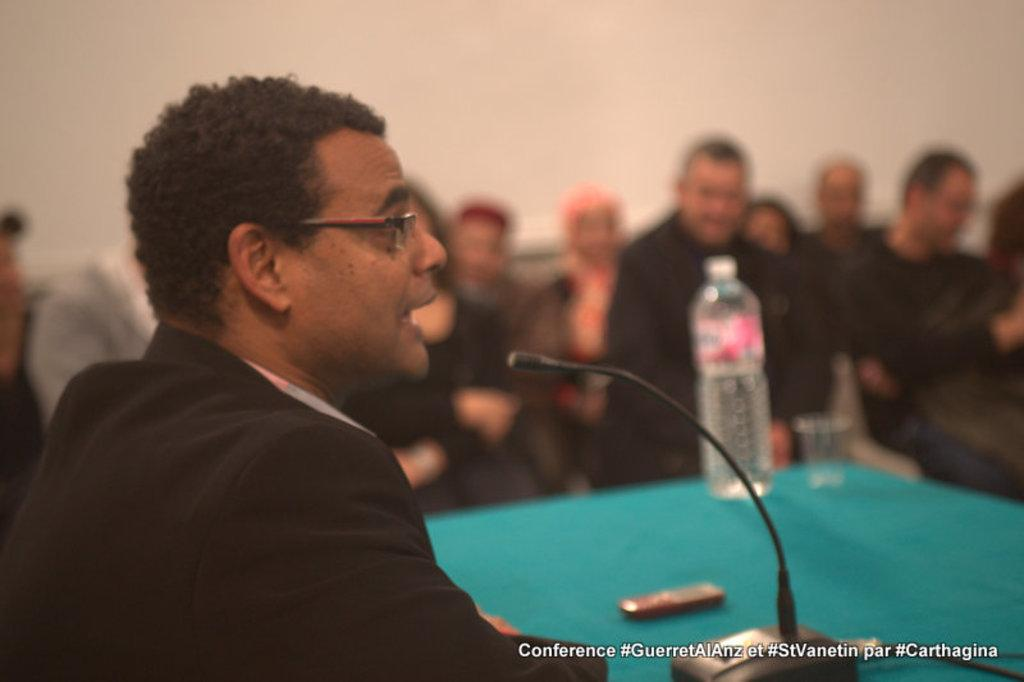What is the man at the left side of the image doing? The man is sitting at the left side of the image and speaking into a microphone. Can you describe the people in the background of the image? There are people sitting in the background of the image. What is the color of the wall in the image? The wall in the image is white. What type of collar is the man wearing in the image? The man is not wearing a collar in the image; he is speaking into a microphone. What is the purpose of the meeting taking place in the image? There is no meeting taking place in the image; it only shows a man sitting at the left side and speaking into a microphone. 